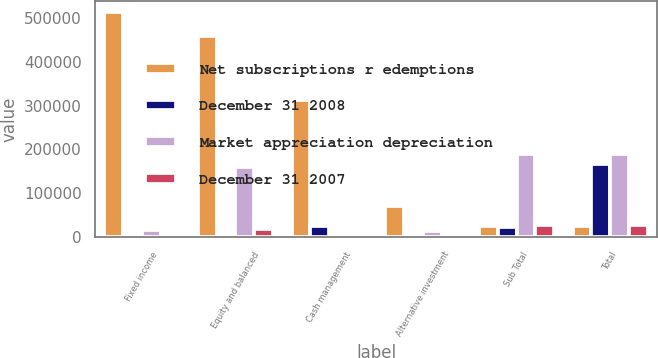Convert chart to OTSL. <chart><loc_0><loc_0><loc_500><loc_500><stacked_bar_chart><ecel><fcel>Fixed income<fcel>Equity and balanced<fcel>Cash management<fcel>Alternative investment<fcel>Sub Total<fcel>Total<nl><fcel>Net subscriptions r edemptions<fcel>513020<fcel>459182<fcel>313338<fcel>71104<fcel>24259<fcel>24259<nl><fcel>December 31 2008<fcel>6594<fcel>869<fcel>25670<fcel>2903<fcel>22848<fcel>167604<nl><fcel>Market appreciation depreciation<fcel>17031<fcel>160448<fcel>1339<fcel>13049<fcel>189189<fcel>188950<nl><fcel>December 31 2007<fcel>6222<fcel>18782<fcel>1908<fcel>1235<fcel>28147<fcel>28147<nl></chart> 